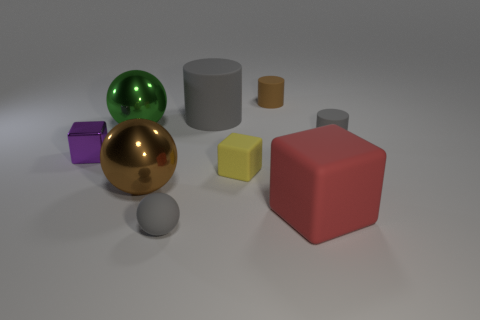Subtract all tiny yellow cubes. How many cubes are left? 2 Subtract 2 balls. How many balls are left? 1 Add 9 gray rubber balls. How many gray rubber balls exist? 10 Subtract all gray cylinders. How many cylinders are left? 1 Subtract 1 gray spheres. How many objects are left? 8 Subtract all cylinders. How many objects are left? 6 Subtract all cyan cylinders. Subtract all cyan blocks. How many cylinders are left? 3 Subtract all brown cylinders. How many purple spheres are left? 0 Subtract all brown balls. Subtract all red rubber cubes. How many objects are left? 7 Add 6 large green objects. How many large green objects are left? 7 